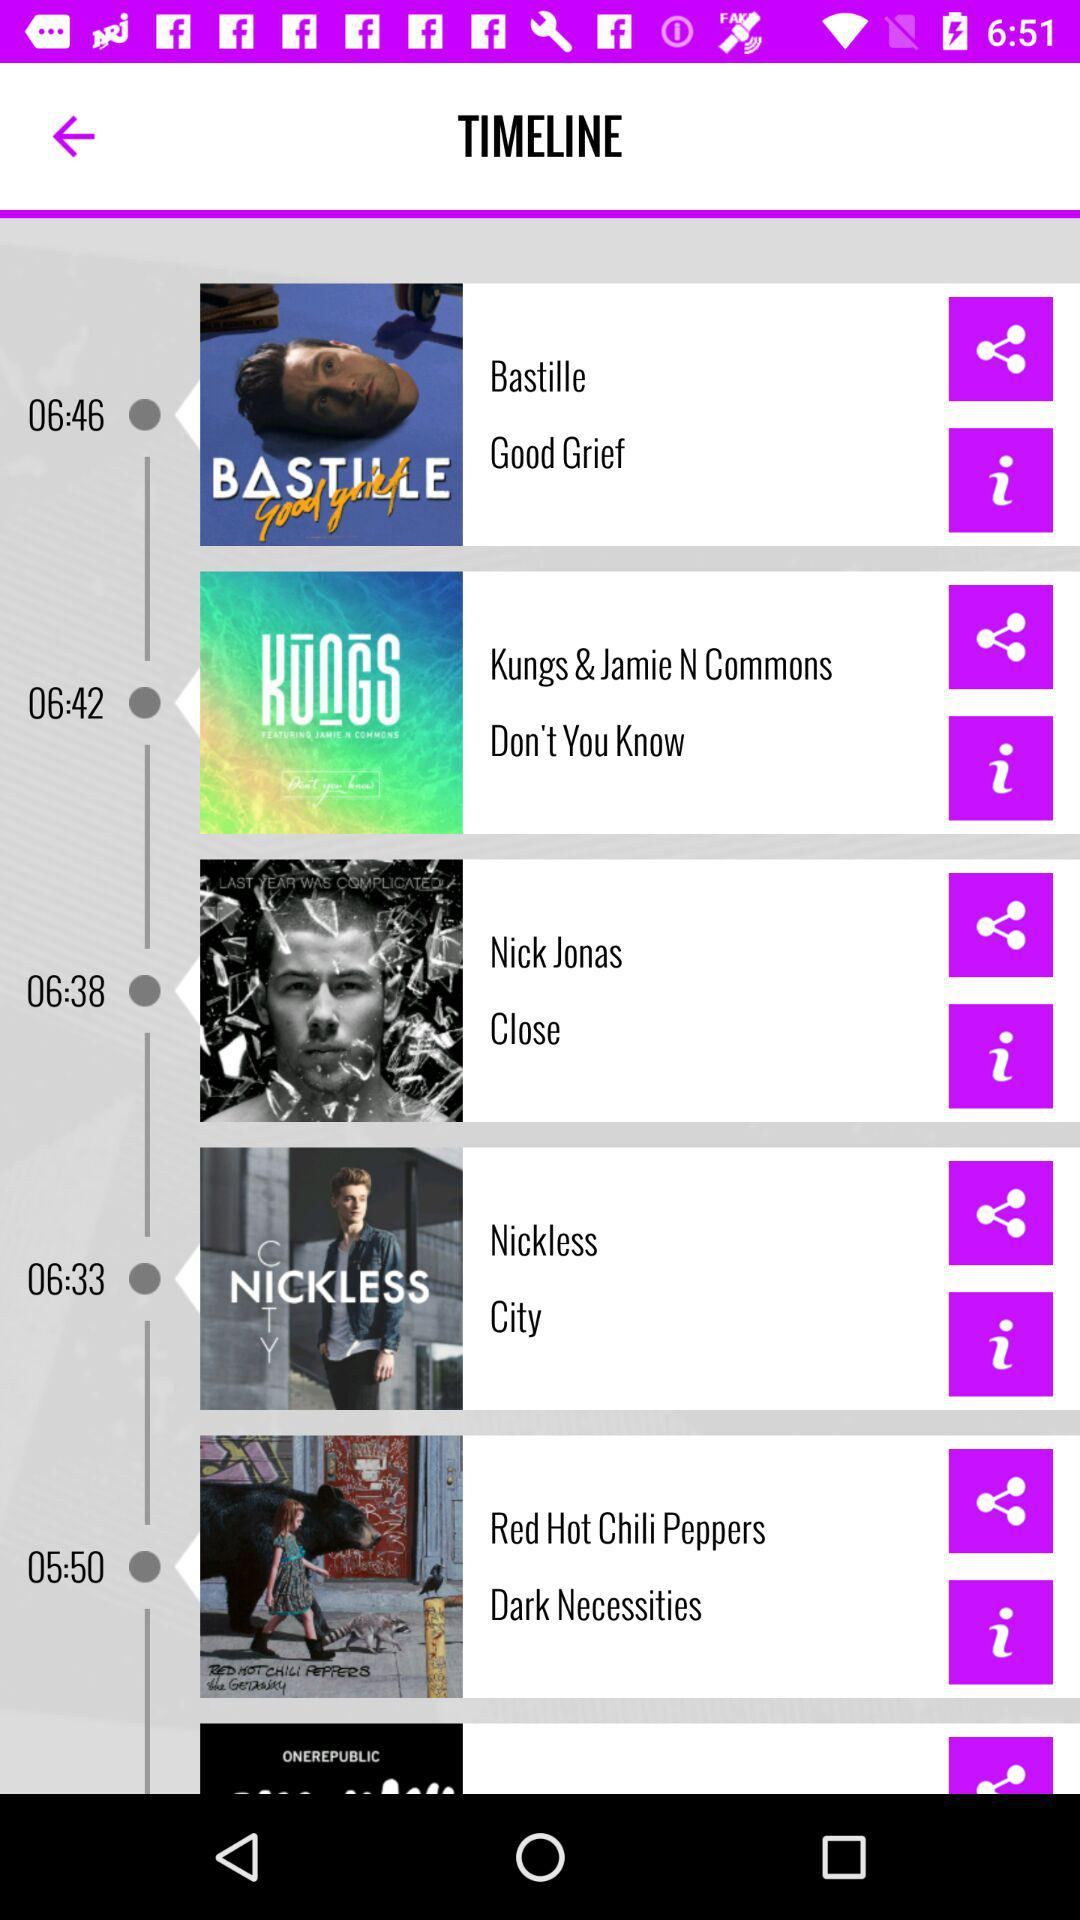What is the duration of the song "Good Grief"? The duration is 6 minutes and 46 seconds. 